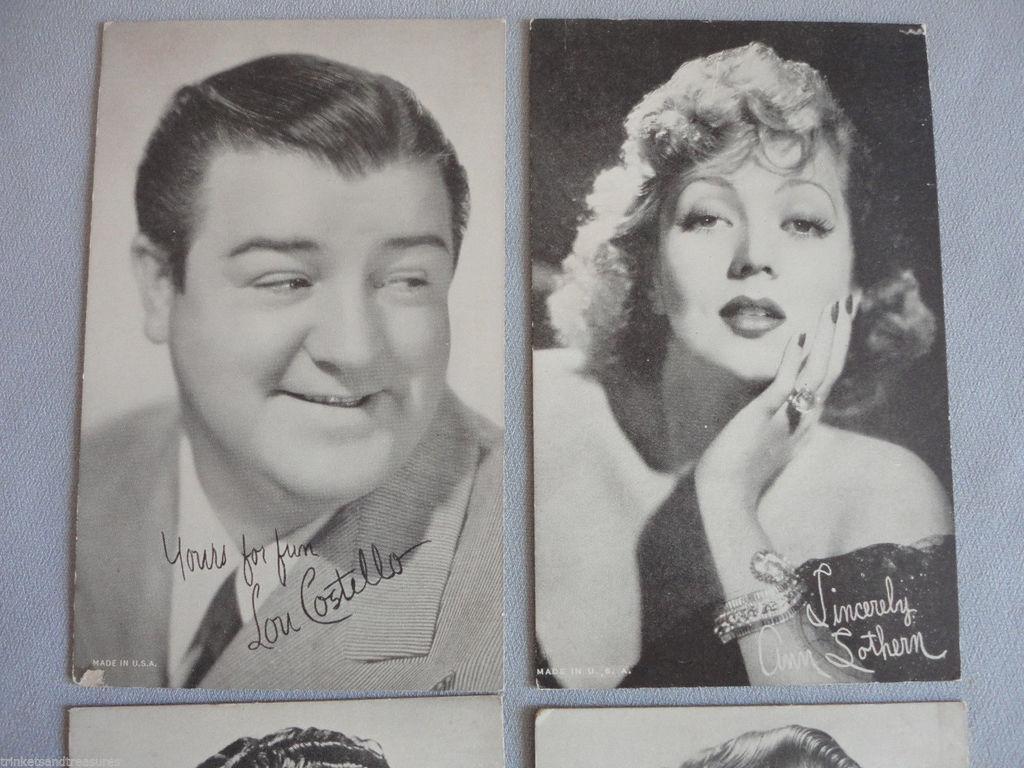Describe this image in one or two sentences. In the image we can see there are photos. In the right side image we can see a woman wearing a bracelet and dress and in the left photo we can see a man wearing clothes and he is smiling. At the bottom left we can see watermark. 